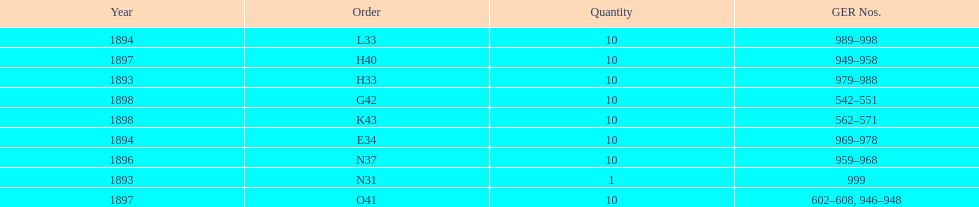Which had more ger numbers, 1898 or 1893? 1898. 